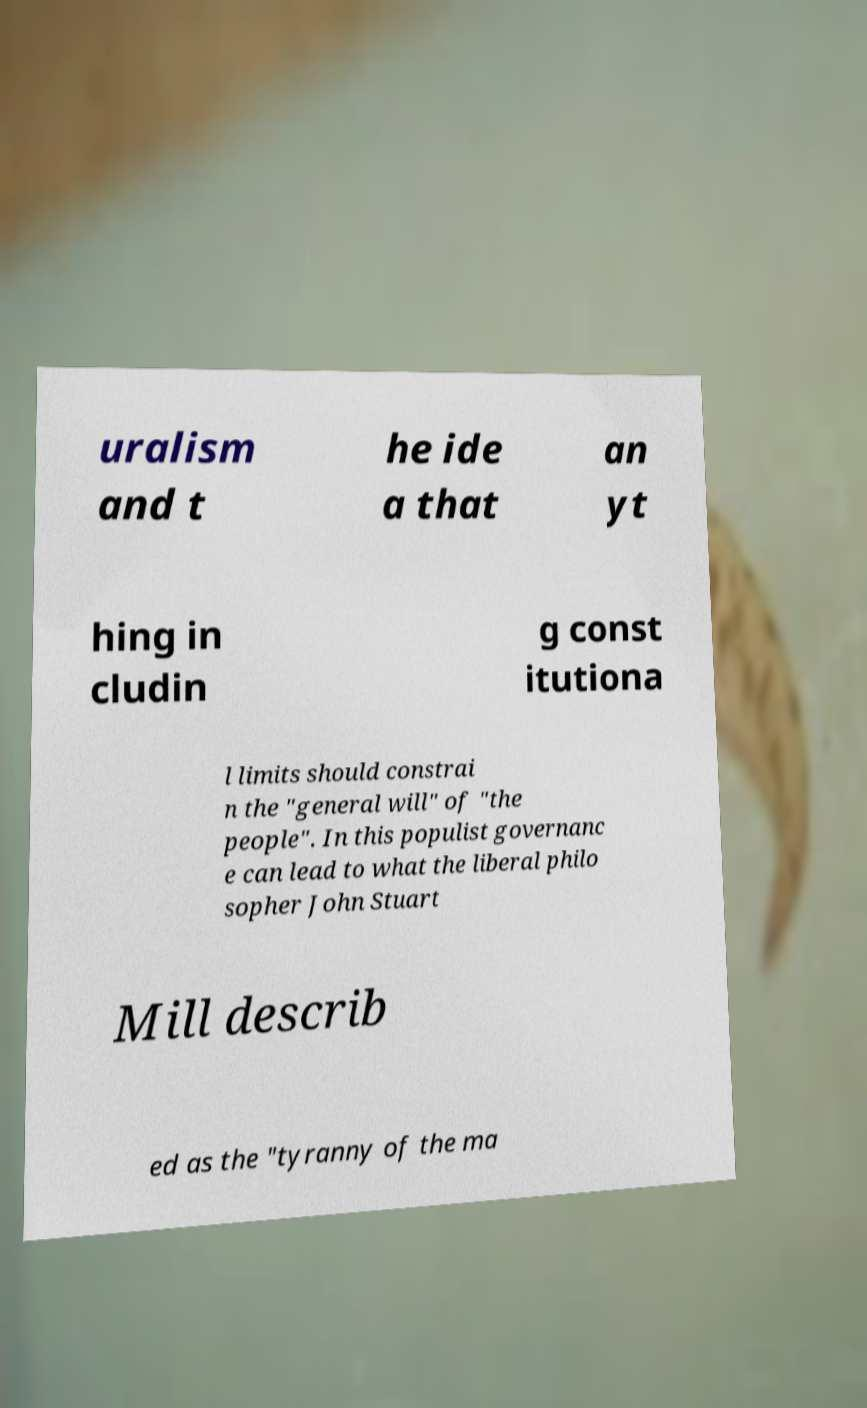I need the written content from this picture converted into text. Can you do that? uralism and t he ide a that an yt hing in cludin g const itutiona l limits should constrai n the "general will" of "the people". In this populist governanc e can lead to what the liberal philo sopher John Stuart Mill describ ed as the "tyranny of the ma 